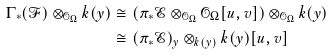<formula> <loc_0><loc_0><loc_500><loc_500>\Gamma _ { * } ( \mathcal { F } ) \otimes _ { \mathcal { O } _ { \Omega } } k ( y ) & \cong ( \pi _ { * } \mathcal { E } \otimes _ { \mathcal { O } _ { \Omega } } \mathcal { O } _ { \Omega } [ u , v ] ) \otimes _ { \mathcal { O } _ { \Omega } } k ( y ) \\ & \cong ( \pi _ { * } \mathcal { E } ) _ { y } \otimes _ { k ( y ) } k ( y ) [ u , v ]</formula> 